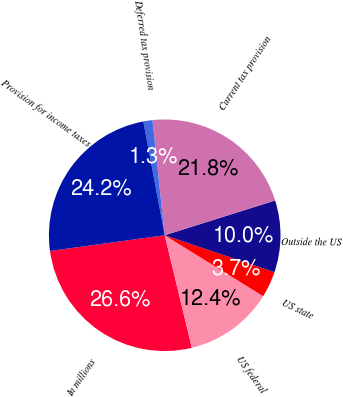Convert chart to OTSL. <chart><loc_0><loc_0><loc_500><loc_500><pie_chart><fcel>In millions<fcel>US federal<fcel>US state<fcel>Outside the US<fcel>Current tax provision<fcel>Deferred tax provision<fcel>Provision for income taxes<nl><fcel>26.6%<fcel>12.41%<fcel>3.66%<fcel>10.02%<fcel>21.83%<fcel>1.27%<fcel>24.22%<nl></chart> 